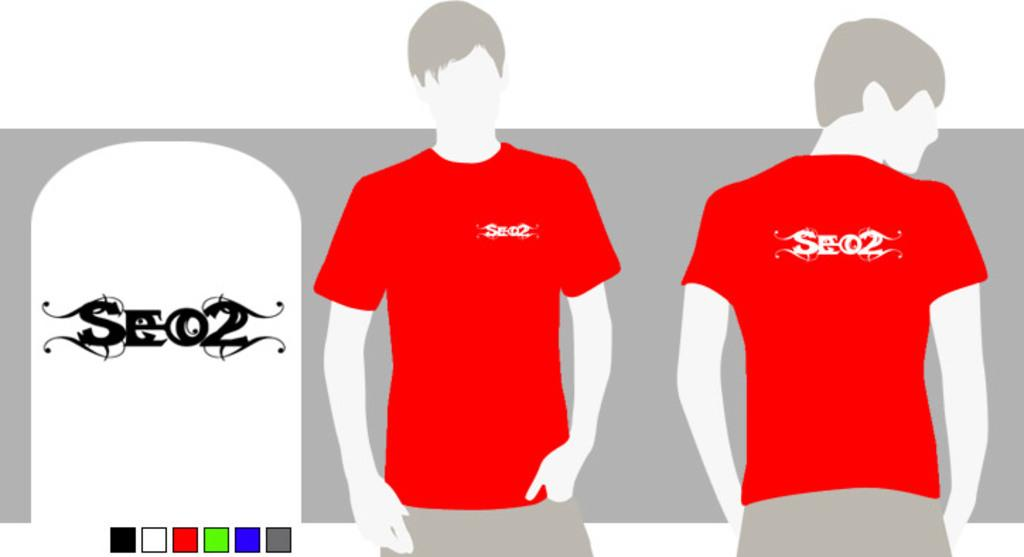<image>
Describe the image concisely. a red shirt that has the letters se02 on it 